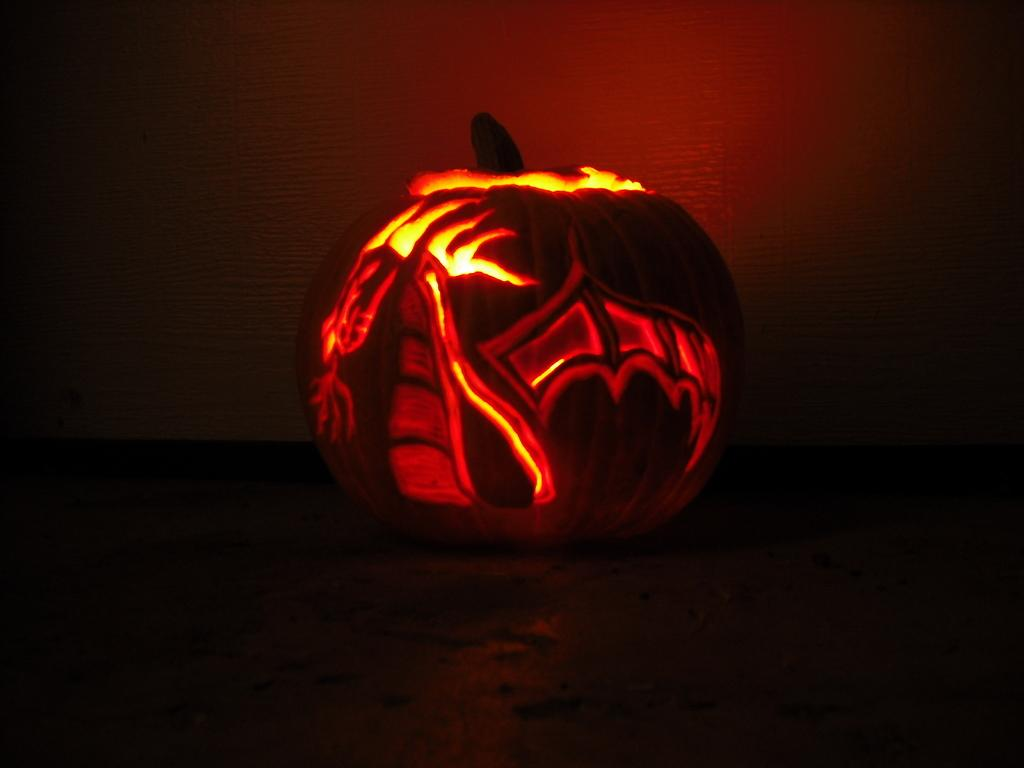What is the main object in the foreground of the image? There is a pumpkin in the foreground of the image. What is the pumpkin resting on? The pumpkin is on a surface. What is a unique feature of the pumpkin? The pumpkin has a light inside it. What can be seen in the background of the image? There is a wall in the background of the image. What type of calculator is sitting next to the pumpkin in the image? There is no calculator present in the image. Can you tell me how many dolls are interacting with the pumpkin in the image? There are no dolls present in the image. 